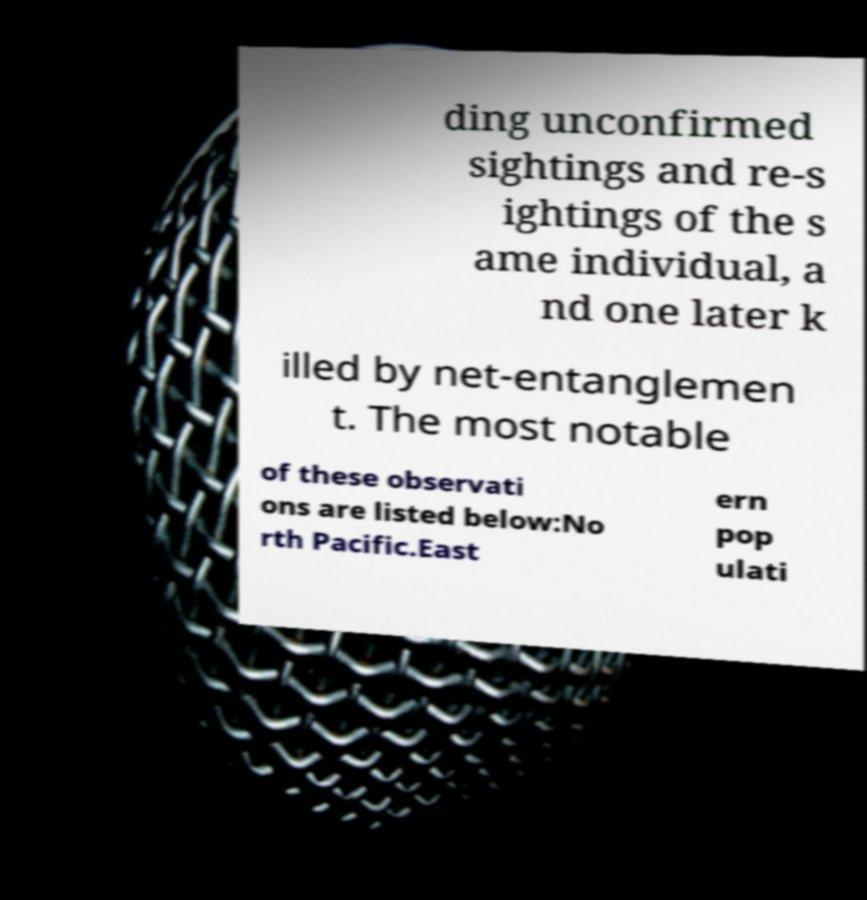There's text embedded in this image that I need extracted. Can you transcribe it verbatim? ding unconfirmed sightings and re-s ightings of the s ame individual, a nd one later k illed by net-entanglemen t. The most notable of these observati ons are listed below:No rth Pacific.East ern pop ulati 